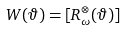Convert formula to latex. <formula><loc_0><loc_0><loc_500><loc_500>W ( \vartheta ) = [ R _ { \omega } ^ { \otimes } ( \vartheta ) ]</formula> 